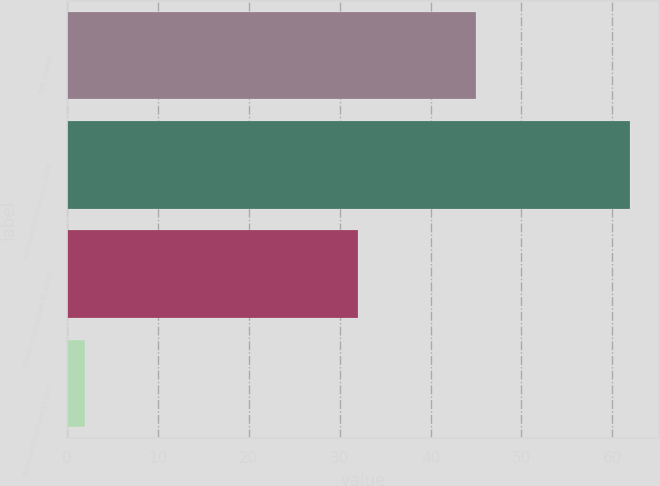Convert chart. <chart><loc_0><loc_0><loc_500><loc_500><bar_chart><fcel>Net change<fcel>Balance December 31 2015<fcel>Balance December 31 2016<fcel>Balance December 31 2017<nl><fcel>45<fcel>62<fcel>32<fcel>2<nl></chart> 